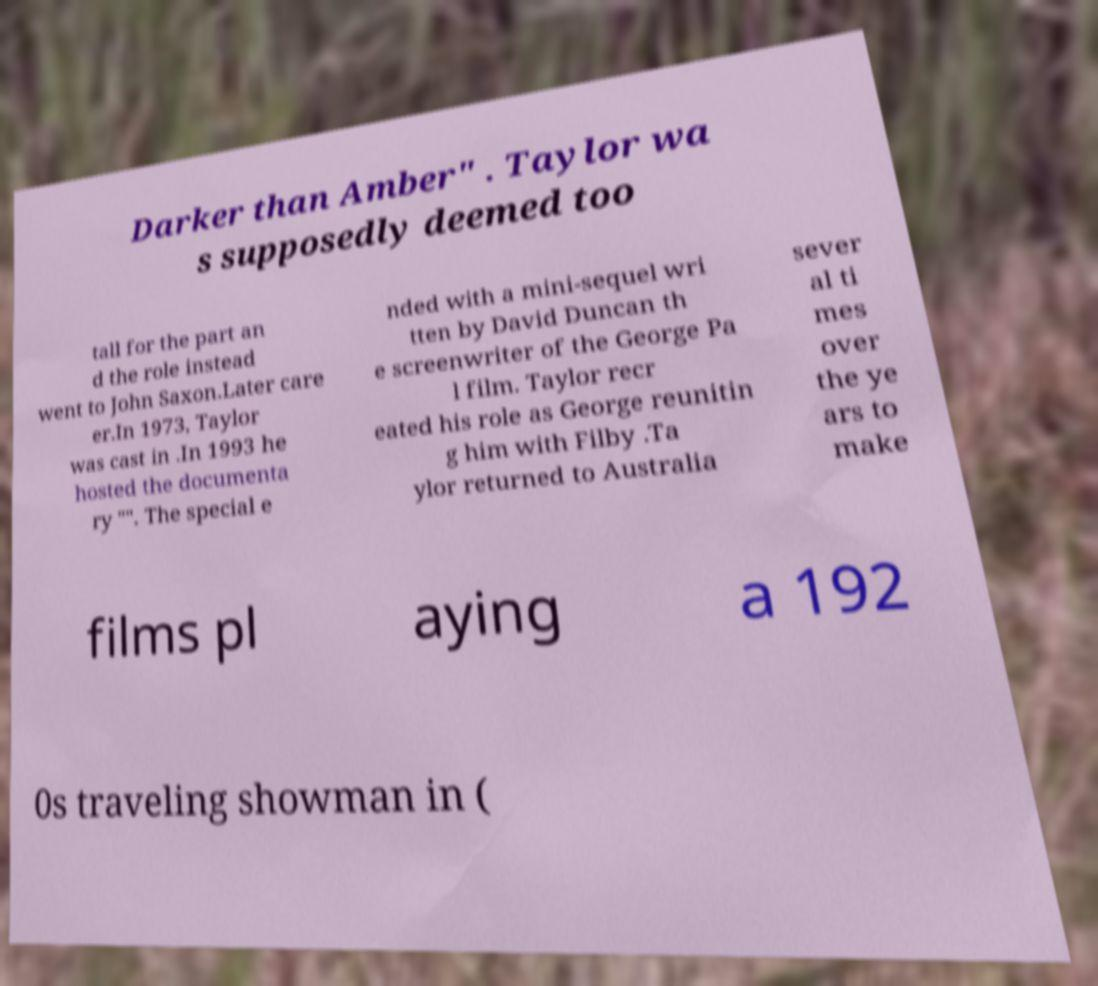I need the written content from this picture converted into text. Can you do that? Darker than Amber" . Taylor wa s supposedly deemed too tall for the part an d the role instead went to John Saxon.Later care er.In 1973, Taylor was cast in .In 1993 he hosted the documenta ry "". The special e nded with a mini-sequel wri tten by David Duncan th e screenwriter of the George Pa l film. Taylor recr eated his role as George reunitin g him with Filby .Ta ylor returned to Australia sever al ti mes over the ye ars to make films pl aying a 192 0s traveling showman in ( 